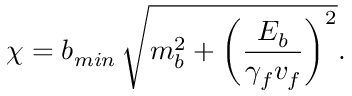<formula> <loc_0><loc_0><loc_500><loc_500>\chi = b _ { \min } \, \sqrt { m _ { b } ^ { 2 } + \left ( \frac { E _ { b } } { \gamma _ { f } v _ { f } } \right ) ^ { 2 } } .</formula> 